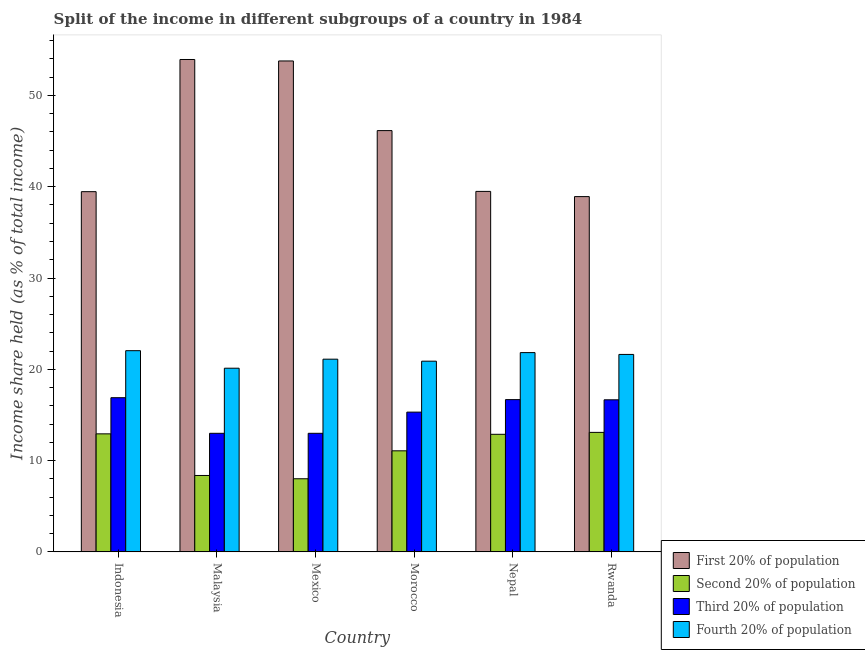How many different coloured bars are there?
Your answer should be very brief. 4. Are the number of bars per tick equal to the number of legend labels?
Make the answer very short. Yes. What is the label of the 4th group of bars from the left?
Offer a very short reply. Morocco. In how many cases, is the number of bars for a given country not equal to the number of legend labels?
Offer a very short reply. 0. What is the share of the income held by first 20% of the population in Malaysia?
Ensure brevity in your answer.  53.94. Across all countries, what is the maximum share of the income held by fourth 20% of the population?
Offer a terse response. 22.04. Across all countries, what is the minimum share of the income held by second 20% of the population?
Make the answer very short. 8.01. In which country was the share of the income held by second 20% of the population maximum?
Offer a terse response. Rwanda. What is the total share of the income held by first 20% of the population in the graph?
Offer a terse response. 271.74. What is the difference between the share of the income held by fourth 20% of the population in Malaysia and that in Morocco?
Offer a terse response. -0.77. What is the difference between the share of the income held by fourth 20% of the population in Mexico and the share of the income held by first 20% of the population in Morocco?
Keep it short and to the point. -25.04. What is the average share of the income held by third 20% of the population per country?
Offer a terse response. 15.25. What is the difference between the share of the income held by fourth 20% of the population and share of the income held by second 20% of the population in Mexico?
Your answer should be very brief. 13.1. In how many countries, is the share of the income held by first 20% of the population greater than 28 %?
Give a very brief answer. 6. What is the ratio of the share of the income held by fourth 20% of the population in Malaysia to that in Morocco?
Keep it short and to the point. 0.96. Is the difference between the share of the income held by third 20% of the population in Malaysia and Nepal greater than the difference between the share of the income held by first 20% of the population in Malaysia and Nepal?
Your answer should be very brief. No. What is the difference between the highest and the second highest share of the income held by second 20% of the population?
Your answer should be compact. 0.16. What is the difference between the highest and the lowest share of the income held by second 20% of the population?
Offer a terse response. 5.08. In how many countries, is the share of the income held by second 20% of the population greater than the average share of the income held by second 20% of the population taken over all countries?
Make the answer very short. 4. Is the sum of the share of the income held by second 20% of the population in Malaysia and Nepal greater than the maximum share of the income held by first 20% of the population across all countries?
Your answer should be compact. No. What does the 4th bar from the left in Nepal represents?
Make the answer very short. Fourth 20% of population. What does the 1st bar from the right in Indonesia represents?
Keep it short and to the point. Fourth 20% of population. How many bars are there?
Make the answer very short. 24. Are all the bars in the graph horizontal?
Offer a very short reply. No. How many countries are there in the graph?
Offer a terse response. 6. What is the difference between two consecutive major ticks on the Y-axis?
Your answer should be very brief. 10. Does the graph contain any zero values?
Your answer should be compact. No. Where does the legend appear in the graph?
Ensure brevity in your answer.  Bottom right. How many legend labels are there?
Make the answer very short. 4. What is the title of the graph?
Your response must be concise. Split of the income in different subgroups of a country in 1984. What is the label or title of the X-axis?
Keep it short and to the point. Country. What is the label or title of the Y-axis?
Your answer should be compact. Income share held (as % of total income). What is the Income share held (as % of total income) in First 20% of population in Indonesia?
Your answer should be very brief. 39.46. What is the Income share held (as % of total income) in Second 20% of population in Indonesia?
Provide a succinct answer. 12.93. What is the Income share held (as % of total income) of Third 20% of population in Indonesia?
Provide a short and direct response. 16.89. What is the Income share held (as % of total income) of Fourth 20% of population in Indonesia?
Provide a succinct answer. 22.04. What is the Income share held (as % of total income) in First 20% of population in Malaysia?
Give a very brief answer. 53.94. What is the Income share held (as % of total income) in Second 20% of population in Malaysia?
Provide a short and direct response. 8.37. What is the Income share held (as % of total income) in Third 20% of population in Malaysia?
Your answer should be very brief. 12.99. What is the Income share held (as % of total income) of Fourth 20% of population in Malaysia?
Provide a succinct answer. 20.12. What is the Income share held (as % of total income) of First 20% of population in Mexico?
Your answer should be very brief. 53.78. What is the Income share held (as % of total income) in Second 20% of population in Mexico?
Offer a very short reply. 8.01. What is the Income share held (as % of total income) in Third 20% of population in Mexico?
Keep it short and to the point. 12.99. What is the Income share held (as % of total income) in Fourth 20% of population in Mexico?
Keep it short and to the point. 21.11. What is the Income share held (as % of total income) in First 20% of population in Morocco?
Keep it short and to the point. 46.15. What is the Income share held (as % of total income) in Second 20% of population in Morocco?
Offer a very short reply. 11.07. What is the Income share held (as % of total income) of Third 20% of population in Morocco?
Offer a very short reply. 15.31. What is the Income share held (as % of total income) in Fourth 20% of population in Morocco?
Give a very brief answer. 20.89. What is the Income share held (as % of total income) of First 20% of population in Nepal?
Give a very brief answer. 39.49. What is the Income share held (as % of total income) of Second 20% of population in Nepal?
Give a very brief answer. 12.88. What is the Income share held (as % of total income) of Third 20% of population in Nepal?
Offer a terse response. 16.68. What is the Income share held (as % of total income) in Fourth 20% of population in Nepal?
Provide a short and direct response. 21.83. What is the Income share held (as % of total income) of First 20% of population in Rwanda?
Provide a succinct answer. 38.92. What is the Income share held (as % of total income) of Second 20% of population in Rwanda?
Offer a very short reply. 13.09. What is the Income share held (as % of total income) in Third 20% of population in Rwanda?
Provide a succinct answer. 16.66. What is the Income share held (as % of total income) of Fourth 20% of population in Rwanda?
Offer a terse response. 21.63. Across all countries, what is the maximum Income share held (as % of total income) in First 20% of population?
Offer a very short reply. 53.94. Across all countries, what is the maximum Income share held (as % of total income) in Second 20% of population?
Keep it short and to the point. 13.09. Across all countries, what is the maximum Income share held (as % of total income) of Third 20% of population?
Offer a terse response. 16.89. Across all countries, what is the maximum Income share held (as % of total income) of Fourth 20% of population?
Keep it short and to the point. 22.04. Across all countries, what is the minimum Income share held (as % of total income) in First 20% of population?
Make the answer very short. 38.92. Across all countries, what is the minimum Income share held (as % of total income) in Second 20% of population?
Offer a very short reply. 8.01. Across all countries, what is the minimum Income share held (as % of total income) in Third 20% of population?
Ensure brevity in your answer.  12.99. Across all countries, what is the minimum Income share held (as % of total income) of Fourth 20% of population?
Provide a short and direct response. 20.12. What is the total Income share held (as % of total income) in First 20% of population in the graph?
Offer a very short reply. 271.74. What is the total Income share held (as % of total income) in Second 20% of population in the graph?
Provide a short and direct response. 66.35. What is the total Income share held (as % of total income) of Third 20% of population in the graph?
Offer a terse response. 91.52. What is the total Income share held (as % of total income) of Fourth 20% of population in the graph?
Provide a succinct answer. 127.62. What is the difference between the Income share held (as % of total income) in First 20% of population in Indonesia and that in Malaysia?
Your answer should be compact. -14.48. What is the difference between the Income share held (as % of total income) of Second 20% of population in Indonesia and that in Malaysia?
Provide a short and direct response. 4.56. What is the difference between the Income share held (as % of total income) in Fourth 20% of population in Indonesia and that in Malaysia?
Provide a short and direct response. 1.92. What is the difference between the Income share held (as % of total income) of First 20% of population in Indonesia and that in Mexico?
Keep it short and to the point. -14.32. What is the difference between the Income share held (as % of total income) in Second 20% of population in Indonesia and that in Mexico?
Ensure brevity in your answer.  4.92. What is the difference between the Income share held (as % of total income) in Fourth 20% of population in Indonesia and that in Mexico?
Make the answer very short. 0.93. What is the difference between the Income share held (as % of total income) of First 20% of population in Indonesia and that in Morocco?
Provide a short and direct response. -6.69. What is the difference between the Income share held (as % of total income) of Second 20% of population in Indonesia and that in Morocco?
Provide a short and direct response. 1.86. What is the difference between the Income share held (as % of total income) in Third 20% of population in Indonesia and that in Morocco?
Keep it short and to the point. 1.58. What is the difference between the Income share held (as % of total income) in Fourth 20% of population in Indonesia and that in Morocco?
Provide a succinct answer. 1.15. What is the difference between the Income share held (as % of total income) in First 20% of population in Indonesia and that in Nepal?
Your response must be concise. -0.03. What is the difference between the Income share held (as % of total income) in Second 20% of population in Indonesia and that in Nepal?
Give a very brief answer. 0.05. What is the difference between the Income share held (as % of total income) in Third 20% of population in Indonesia and that in Nepal?
Ensure brevity in your answer.  0.21. What is the difference between the Income share held (as % of total income) of Fourth 20% of population in Indonesia and that in Nepal?
Your answer should be compact. 0.21. What is the difference between the Income share held (as % of total income) in First 20% of population in Indonesia and that in Rwanda?
Your answer should be compact. 0.54. What is the difference between the Income share held (as % of total income) of Second 20% of population in Indonesia and that in Rwanda?
Offer a very short reply. -0.16. What is the difference between the Income share held (as % of total income) in Third 20% of population in Indonesia and that in Rwanda?
Your response must be concise. 0.23. What is the difference between the Income share held (as % of total income) in Fourth 20% of population in Indonesia and that in Rwanda?
Your answer should be compact. 0.41. What is the difference between the Income share held (as % of total income) in First 20% of population in Malaysia and that in Mexico?
Give a very brief answer. 0.16. What is the difference between the Income share held (as % of total income) in Second 20% of population in Malaysia and that in Mexico?
Provide a short and direct response. 0.36. What is the difference between the Income share held (as % of total income) in Fourth 20% of population in Malaysia and that in Mexico?
Offer a very short reply. -0.99. What is the difference between the Income share held (as % of total income) of First 20% of population in Malaysia and that in Morocco?
Offer a very short reply. 7.79. What is the difference between the Income share held (as % of total income) in Third 20% of population in Malaysia and that in Morocco?
Keep it short and to the point. -2.32. What is the difference between the Income share held (as % of total income) in Fourth 20% of population in Malaysia and that in Morocco?
Provide a succinct answer. -0.77. What is the difference between the Income share held (as % of total income) in First 20% of population in Malaysia and that in Nepal?
Keep it short and to the point. 14.45. What is the difference between the Income share held (as % of total income) in Second 20% of population in Malaysia and that in Nepal?
Offer a terse response. -4.51. What is the difference between the Income share held (as % of total income) of Third 20% of population in Malaysia and that in Nepal?
Give a very brief answer. -3.69. What is the difference between the Income share held (as % of total income) of Fourth 20% of population in Malaysia and that in Nepal?
Your response must be concise. -1.71. What is the difference between the Income share held (as % of total income) in First 20% of population in Malaysia and that in Rwanda?
Your answer should be compact. 15.02. What is the difference between the Income share held (as % of total income) in Second 20% of population in Malaysia and that in Rwanda?
Provide a succinct answer. -4.72. What is the difference between the Income share held (as % of total income) in Third 20% of population in Malaysia and that in Rwanda?
Ensure brevity in your answer.  -3.67. What is the difference between the Income share held (as % of total income) of Fourth 20% of population in Malaysia and that in Rwanda?
Make the answer very short. -1.51. What is the difference between the Income share held (as % of total income) of First 20% of population in Mexico and that in Morocco?
Your answer should be very brief. 7.63. What is the difference between the Income share held (as % of total income) in Second 20% of population in Mexico and that in Morocco?
Offer a very short reply. -3.06. What is the difference between the Income share held (as % of total income) of Third 20% of population in Mexico and that in Morocco?
Ensure brevity in your answer.  -2.32. What is the difference between the Income share held (as % of total income) in Fourth 20% of population in Mexico and that in Morocco?
Give a very brief answer. 0.22. What is the difference between the Income share held (as % of total income) of First 20% of population in Mexico and that in Nepal?
Your answer should be compact. 14.29. What is the difference between the Income share held (as % of total income) in Second 20% of population in Mexico and that in Nepal?
Ensure brevity in your answer.  -4.87. What is the difference between the Income share held (as % of total income) in Third 20% of population in Mexico and that in Nepal?
Your answer should be very brief. -3.69. What is the difference between the Income share held (as % of total income) of Fourth 20% of population in Mexico and that in Nepal?
Make the answer very short. -0.72. What is the difference between the Income share held (as % of total income) in First 20% of population in Mexico and that in Rwanda?
Your answer should be very brief. 14.86. What is the difference between the Income share held (as % of total income) of Second 20% of population in Mexico and that in Rwanda?
Provide a short and direct response. -5.08. What is the difference between the Income share held (as % of total income) in Third 20% of population in Mexico and that in Rwanda?
Provide a short and direct response. -3.67. What is the difference between the Income share held (as % of total income) in Fourth 20% of population in Mexico and that in Rwanda?
Ensure brevity in your answer.  -0.52. What is the difference between the Income share held (as % of total income) of First 20% of population in Morocco and that in Nepal?
Your answer should be compact. 6.66. What is the difference between the Income share held (as % of total income) in Second 20% of population in Morocco and that in Nepal?
Ensure brevity in your answer.  -1.81. What is the difference between the Income share held (as % of total income) in Third 20% of population in Morocco and that in Nepal?
Provide a short and direct response. -1.37. What is the difference between the Income share held (as % of total income) in Fourth 20% of population in Morocco and that in Nepal?
Your answer should be compact. -0.94. What is the difference between the Income share held (as % of total income) of First 20% of population in Morocco and that in Rwanda?
Your answer should be compact. 7.23. What is the difference between the Income share held (as % of total income) of Second 20% of population in Morocco and that in Rwanda?
Offer a terse response. -2.02. What is the difference between the Income share held (as % of total income) in Third 20% of population in Morocco and that in Rwanda?
Provide a succinct answer. -1.35. What is the difference between the Income share held (as % of total income) in Fourth 20% of population in Morocco and that in Rwanda?
Your answer should be very brief. -0.74. What is the difference between the Income share held (as % of total income) of First 20% of population in Nepal and that in Rwanda?
Your answer should be very brief. 0.57. What is the difference between the Income share held (as % of total income) of Second 20% of population in Nepal and that in Rwanda?
Provide a short and direct response. -0.21. What is the difference between the Income share held (as % of total income) in Third 20% of population in Nepal and that in Rwanda?
Ensure brevity in your answer.  0.02. What is the difference between the Income share held (as % of total income) of Fourth 20% of population in Nepal and that in Rwanda?
Provide a short and direct response. 0.2. What is the difference between the Income share held (as % of total income) of First 20% of population in Indonesia and the Income share held (as % of total income) of Second 20% of population in Malaysia?
Provide a succinct answer. 31.09. What is the difference between the Income share held (as % of total income) of First 20% of population in Indonesia and the Income share held (as % of total income) of Third 20% of population in Malaysia?
Make the answer very short. 26.47. What is the difference between the Income share held (as % of total income) of First 20% of population in Indonesia and the Income share held (as % of total income) of Fourth 20% of population in Malaysia?
Provide a succinct answer. 19.34. What is the difference between the Income share held (as % of total income) of Second 20% of population in Indonesia and the Income share held (as % of total income) of Third 20% of population in Malaysia?
Your response must be concise. -0.06. What is the difference between the Income share held (as % of total income) of Second 20% of population in Indonesia and the Income share held (as % of total income) of Fourth 20% of population in Malaysia?
Offer a very short reply. -7.19. What is the difference between the Income share held (as % of total income) in Third 20% of population in Indonesia and the Income share held (as % of total income) in Fourth 20% of population in Malaysia?
Offer a terse response. -3.23. What is the difference between the Income share held (as % of total income) in First 20% of population in Indonesia and the Income share held (as % of total income) in Second 20% of population in Mexico?
Give a very brief answer. 31.45. What is the difference between the Income share held (as % of total income) in First 20% of population in Indonesia and the Income share held (as % of total income) in Third 20% of population in Mexico?
Ensure brevity in your answer.  26.47. What is the difference between the Income share held (as % of total income) in First 20% of population in Indonesia and the Income share held (as % of total income) in Fourth 20% of population in Mexico?
Ensure brevity in your answer.  18.35. What is the difference between the Income share held (as % of total income) of Second 20% of population in Indonesia and the Income share held (as % of total income) of Third 20% of population in Mexico?
Ensure brevity in your answer.  -0.06. What is the difference between the Income share held (as % of total income) in Second 20% of population in Indonesia and the Income share held (as % of total income) in Fourth 20% of population in Mexico?
Provide a succinct answer. -8.18. What is the difference between the Income share held (as % of total income) in Third 20% of population in Indonesia and the Income share held (as % of total income) in Fourth 20% of population in Mexico?
Give a very brief answer. -4.22. What is the difference between the Income share held (as % of total income) of First 20% of population in Indonesia and the Income share held (as % of total income) of Second 20% of population in Morocco?
Give a very brief answer. 28.39. What is the difference between the Income share held (as % of total income) of First 20% of population in Indonesia and the Income share held (as % of total income) of Third 20% of population in Morocco?
Offer a terse response. 24.15. What is the difference between the Income share held (as % of total income) of First 20% of population in Indonesia and the Income share held (as % of total income) of Fourth 20% of population in Morocco?
Offer a terse response. 18.57. What is the difference between the Income share held (as % of total income) in Second 20% of population in Indonesia and the Income share held (as % of total income) in Third 20% of population in Morocco?
Your answer should be compact. -2.38. What is the difference between the Income share held (as % of total income) of Second 20% of population in Indonesia and the Income share held (as % of total income) of Fourth 20% of population in Morocco?
Provide a succinct answer. -7.96. What is the difference between the Income share held (as % of total income) of Third 20% of population in Indonesia and the Income share held (as % of total income) of Fourth 20% of population in Morocco?
Your answer should be compact. -4. What is the difference between the Income share held (as % of total income) of First 20% of population in Indonesia and the Income share held (as % of total income) of Second 20% of population in Nepal?
Make the answer very short. 26.58. What is the difference between the Income share held (as % of total income) in First 20% of population in Indonesia and the Income share held (as % of total income) in Third 20% of population in Nepal?
Keep it short and to the point. 22.78. What is the difference between the Income share held (as % of total income) in First 20% of population in Indonesia and the Income share held (as % of total income) in Fourth 20% of population in Nepal?
Ensure brevity in your answer.  17.63. What is the difference between the Income share held (as % of total income) in Second 20% of population in Indonesia and the Income share held (as % of total income) in Third 20% of population in Nepal?
Keep it short and to the point. -3.75. What is the difference between the Income share held (as % of total income) in Second 20% of population in Indonesia and the Income share held (as % of total income) in Fourth 20% of population in Nepal?
Give a very brief answer. -8.9. What is the difference between the Income share held (as % of total income) in Third 20% of population in Indonesia and the Income share held (as % of total income) in Fourth 20% of population in Nepal?
Make the answer very short. -4.94. What is the difference between the Income share held (as % of total income) of First 20% of population in Indonesia and the Income share held (as % of total income) of Second 20% of population in Rwanda?
Your answer should be very brief. 26.37. What is the difference between the Income share held (as % of total income) in First 20% of population in Indonesia and the Income share held (as % of total income) in Third 20% of population in Rwanda?
Provide a short and direct response. 22.8. What is the difference between the Income share held (as % of total income) of First 20% of population in Indonesia and the Income share held (as % of total income) of Fourth 20% of population in Rwanda?
Ensure brevity in your answer.  17.83. What is the difference between the Income share held (as % of total income) of Second 20% of population in Indonesia and the Income share held (as % of total income) of Third 20% of population in Rwanda?
Offer a terse response. -3.73. What is the difference between the Income share held (as % of total income) in Third 20% of population in Indonesia and the Income share held (as % of total income) in Fourth 20% of population in Rwanda?
Provide a short and direct response. -4.74. What is the difference between the Income share held (as % of total income) of First 20% of population in Malaysia and the Income share held (as % of total income) of Second 20% of population in Mexico?
Offer a very short reply. 45.93. What is the difference between the Income share held (as % of total income) of First 20% of population in Malaysia and the Income share held (as % of total income) of Third 20% of population in Mexico?
Keep it short and to the point. 40.95. What is the difference between the Income share held (as % of total income) of First 20% of population in Malaysia and the Income share held (as % of total income) of Fourth 20% of population in Mexico?
Offer a terse response. 32.83. What is the difference between the Income share held (as % of total income) in Second 20% of population in Malaysia and the Income share held (as % of total income) in Third 20% of population in Mexico?
Ensure brevity in your answer.  -4.62. What is the difference between the Income share held (as % of total income) in Second 20% of population in Malaysia and the Income share held (as % of total income) in Fourth 20% of population in Mexico?
Your answer should be very brief. -12.74. What is the difference between the Income share held (as % of total income) in Third 20% of population in Malaysia and the Income share held (as % of total income) in Fourth 20% of population in Mexico?
Keep it short and to the point. -8.12. What is the difference between the Income share held (as % of total income) of First 20% of population in Malaysia and the Income share held (as % of total income) of Second 20% of population in Morocco?
Provide a short and direct response. 42.87. What is the difference between the Income share held (as % of total income) of First 20% of population in Malaysia and the Income share held (as % of total income) of Third 20% of population in Morocco?
Offer a terse response. 38.63. What is the difference between the Income share held (as % of total income) of First 20% of population in Malaysia and the Income share held (as % of total income) of Fourth 20% of population in Morocco?
Your response must be concise. 33.05. What is the difference between the Income share held (as % of total income) of Second 20% of population in Malaysia and the Income share held (as % of total income) of Third 20% of population in Morocco?
Your answer should be very brief. -6.94. What is the difference between the Income share held (as % of total income) in Second 20% of population in Malaysia and the Income share held (as % of total income) in Fourth 20% of population in Morocco?
Provide a succinct answer. -12.52. What is the difference between the Income share held (as % of total income) in First 20% of population in Malaysia and the Income share held (as % of total income) in Second 20% of population in Nepal?
Make the answer very short. 41.06. What is the difference between the Income share held (as % of total income) of First 20% of population in Malaysia and the Income share held (as % of total income) of Third 20% of population in Nepal?
Give a very brief answer. 37.26. What is the difference between the Income share held (as % of total income) in First 20% of population in Malaysia and the Income share held (as % of total income) in Fourth 20% of population in Nepal?
Provide a short and direct response. 32.11. What is the difference between the Income share held (as % of total income) of Second 20% of population in Malaysia and the Income share held (as % of total income) of Third 20% of population in Nepal?
Provide a succinct answer. -8.31. What is the difference between the Income share held (as % of total income) of Second 20% of population in Malaysia and the Income share held (as % of total income) of Fourth 20% of population in Nepal?
Your answer should be compact. -13.46. What is the difference between the Income share held (as % of total income) in Third 20% of population in Malaysia and the Income share held (as % of total income) in Fourth 20% of population in Nepal?
Your answer should be very brief. -8.84. What is the difference between the Income share held (as % of total income) of First 20% of population in Malaysia and the Income share held (as % of total income) of Second 20% of population in Rwanda?
Your answer should be compact. 40.85. What is the difference between the Income share held (as % of total income) in First 20% of population in Malaysia and the Income share held (as % of total income) in Third 20% of population in Rwanda?
Ensure brevity in your answer.  37.28. What is the difference between the Income share held (as % of total income) of First 20% of population in Malaysia and the Income share held (as % of total income) of Fourth 20% of population in Rwanda?
Offer a very short reply. 32.31. What is the difference between the Income share held (as % of total income) in Second 20% of population in Malaysia and the Income share held (as % of total income) in Third 20% of population in Rwanda?
Your response must be concise. -8.29. What is the difference between the Income share held (as % of total income) in Second 20% of population in Malaysia and the Income share held (as % of total income) in Fourth 20% of population in Rwanda?
Your answer should be very brief. -13.26. What is the difference between the Income share held (as % of total income) of Third 20% of population in Malaysia and the Income share held (as % of total income) of Fourth 20% of population in Rwanda?
Provide a short and direct response. -8.64. What is the difference between the Income share held (as % of total income) in First 20% of population in Mexico and the Income share held (as % of total income) in Second 20% of population in Morocco?
Provide a short and direct response. 42.71. What is the difference between the Income share held (as % of total income) in First 20% of population in Mexico and the Income share held (as % of total income) in Third 20% of population in Morocco?
Provide a short and direct response. 38.47. What is the difference between the Income share held (as % of total income) of First 20% of population in Mexico and the Income share held (as % of total income) of Fourth 20% of population in Morocco?
Your response must be concise. 32.89. What is the difference between the Income share held (as % of total income) in Second 20% of population in Mexico and the Income share held (as % of total income) in Fourth 20% of population in Morocco?
Keep it short and to the point. -12.88. What is the difference between the Income share held (as % of total income) in Third 20% of population in Mexico and the Income share held (as % of total income) in Fourth 20% of population in Morocco?
Ensure brevity in your answer.  -7.9. What is the difference between the Income share held (as % of total income) in First 20% of population in Mexico and the Income share held (as % of total income) in Second 20% of population in Nepal?
Provide a succinct answer. 40.9. What is the difference between the Income share held (as % of total income) of First 20% of population in Mexico and the Income share held (as % of total income) of Third 20% of population in Nepal?
Ensure brevity in your answer.  37.1. What is the difference between the Income share held (as % of total income) in First 20% of population in Mexico and the Income share held (as % of total income) in Fourth 20% of population in Nepal?
Provide a short and direct response. 31.95. What is the difference between the Income share held (as % of total income) of Second 20% of population in Mexico and the Income share held (as % of total income) of Third 20% of population in Nepal?
Keep it short and to the point. -8.67. What is the difference between the Income share held (as % of total income) of Second 20% of population in Mexico and the Income share held (as % of total income) of Fourth 20% of population in Nepal?
Your answer should be very brief. -13.82. What is the difference between the Income share held (as % of total income) in Third 20% of population in Mexico and the Income share held (as % of total income) in Fourth 20% of population in Nepal?
Provide a succinct answer. -8.84. What is the difference between the Income share held (as % of total income) in First 20% of population in Mexico and the Income share held (as % of total income) in Second 20% of population in Rwanda?
Offer a terse response. 40.69. What is the difference between the Income share held (as % of total income) in First 20% of population in Mexico and the Income share held (as % of total income) in Third 20% of population in Rwanda?
Your response must be concise. 37.12. What is the difference between the Income share held (as % of total income) of First 20% of population in Mexico and the Income share held (as % of total income) of Fourth 20% of population in Rwanda?
Offer a very short reply. 32.15. What is the difference between the Income share held (as % of total income) of Second 20% of population in Mexico and the Income share held (as % of total income) of Third 20% of population in Rwanda?
Give a very brief answer. -8.65. What is the difference between the Income share held (as % of total income) in Second 20% of population in Mexico and the Income share held (as % of total income) in Fourth 20% of population in Rwanda?
Ensure brevity in your answer.  -13.62. What is the difference between the Income share held (as % of total income) in Third 20% of population in Mexico and the Income share held (as % of total income) in Fourth 20% of population in Rwanda?
Your answer should be very brief. -8.64. What is the difference between the Income share held (as % of total income) of First 20% of population in Morocco and the Income share held (as % of total income) of Second 20% of population in Nepal?
Provide a short and direct response. 33.27. What is the difference between the Income share held (as % of total income) in First 20% of population in Morocco and the Income share held (as % of total income) in Third 20% of population in Nepal?
Give a very brief answer. 29.47. What is the difference between the Income share held (as % of total income) of First 20% of population in Morocco and the Income share held (as % of total income) of Fourth 20% of population in Nepal?
Your answer should be compact. 24.32. What is the difference between the Income share held (as % of total income) in Second 20% of population in Morocco and the Income share held (as % of total income) in Third 20% of population in Nepal?
Your response must be concise. -5.61. What is the difference between the Income share held (as % of total income) in Second 20% of population in Morocco and the Income share held (as % of total income) in Fourth 20% of population in Nepal?
Keep it short and to the point. -10.76. What is the difference between the Income share held (as % of total income) of Third 20% of population in Morocco and the Income share held (as % of total income) of Fourth 20% of population in Nepal?
Offer a terse response. -6.52. What is the difference between the Income share held (as % of total income) in First 20% of population in Morocco and the Income share held (as % of total income) in Second 20% of population in Rwanda?
Keep it short and to the point. 33.06. What is the difference between the Income share held (as % of total income) of First 20% of population in Morocco and the Income share held (as % of total income) of Third 20% of population in Rwanda?
Your response must be concise. 29.49. What is the difference between the Income share held (as % of total income) in First 20% of population in Morocco and the Income share held (as % of total income) in Fourth 20% of population in Rwanda?
Your answer should be compact. 24.52. What is the difference between the Income share held (as % of total income) in Second 20% of population in Morocco and the Income share held (as % of total income) in Third 20% of population in Rwanda?
Provide a succinct answer. -5.59. What is the difference between the Income share held (as % of total income) in Second 20% of population in Morocco and the Income share held (as % of total income) in Fourth 20% of population in Rwanda?
Keep it short and to the point. -10.56. What is the difference between the Income share held (as % of total income) of Third 20% of population in Morocco and the Income share held (as % of total income) of Fourth 20% of population in Rwanda?
Your answer should be very brief. -6.32. What is the difference between the Income share held (as % of total income) in First 20% of population in Nepal and the Income share held (as % of total income) in Second 20% of population in Rwanda?
Offer a very short reply. 26.4. What is the difference between the Income share held (as % of total income) of First 20% of population in Nepal and the Income share held (as % of total income) of Third 20% of population in Rwanda?
Offer a very short reply. 22.83. What is the difference between the Income share held (as % of total income) of First 20% of population in Nepal and the Income share held (as % of total income) of Fourth 20% of population in Rwanda?
Keep it short and to the point. 17.86. What is the difference between the Income share held (as % of total income) of Second 20% of population in Nepal and the Income share held (as % of total income) of Third 20% of population in Rwanda?
Keep it short and to the point. -3.78. What is the difference between the Income share held (as % of total income) in Second 20% of population in Nepal and the Income share held (as % of total income) in Fourth 20% of population in Rwanda?
Give a very brief answer. -8.75. What is the difference between the Income share held (as % of total income) of Third 20% of population in Nepal and the Income share held (as % of total income) of Fourth 20% of population in Rwanda?
Ensure brevity in your answer.  -4.95. What is the average Income share held (as % of total income) in First 20% of population per country?
Give a very brief answer. 45.29. What is the average Income share held (as % of total income) of Second 20% of population per country?
Offer a terse response. 11.06. What is the average Income share held (as % of total income) of Third 20% of population per country?
Make the answer very short. 15.25. What is the average Income share held (as % of total income) in Fourth 20% of population per country?
Offer a very short reply. 21.27. What is the difference between the Income share held (as % of total income) of First 20% of population and Income share held (as % of total income) of Second 20% of population in Indonesia?
Provide a succinct answer. 26.53. What is the difference between the Income share held (as % of total income) of First 20% of population and Income share held (as % of total income) of Third 20% of population in Indonesia?
Provide a short and direct response. 22.57. What is the difference between the Income share held (as % of total income) in First 20% of population and Income share held (as % of total income) in Fourth 20% of population in Indonesia?
Give a very brief answer. 17.42. What is the difference between the Income share held (as % of total income) in Second 20% of population and Income share held (as % of total income) in Third 20% of population in Indonesia?
Offer a very short reply. -3.96. What is the difference between the Income share held (as % of total income) of Second 20% of population and Income share held (as % of total income) of Fourth 20% of population in Indonesia?
Offer a terse response. -9.11. What is the difference between the Income share held (as % of total income) in Third 20% of population and Income share held (as % of total income) in Fourth 20% of population in Indonesia?
Ensure brevity in your answer.  -5.15. What is the difference between the Income share held (as % of total income) in First 20% of population and Income share held (as % of total income) in Second 20% of population in Malaysia?
Offer a terse response. 45.57. What is the difference between the Income share held (as % of total income) of First 20% of population and Income share held (as % of total income) of Third 20% of population in Malaysia?
Keep it short and to the point. 40.95. What is the difference between the Income share held (as % of total income) in First 20% of population and Income share held (as % of total income) in Fourth 20% of population in Malaysia?
Ensure brevity in your answer.  33.82. What is the difference between the Income share held (as % of total income) of Second 20% of population and Income share held (as % of total income) of Third 20% of population in Malaysia?
Provide a succinct answer. -4.62. What is the difference between the Income share held (as % of total income) of Second 20% of population and Income share held (as % of total income) of Fourth 20% of population in Malaysia?
Offer a terse response. -11.75. What is the difference between the Income share held (as % of total income) of Third 20% of population and Income share held (as % of total income) of Fourth 20% of population in Malaysia?
Offer a very short reply. -7.13. What is the difference between the Income share held (as % of total income) in First 20% of population and Income share held (as % of total income) in Second 20% of population in Mexico?
Keep it short and to the point. 45.77. What is the difference between the Income share held (as % of total income) in First 20% of population and Income share held (as % of total income) in Third 20% of population in Mexico?
Offer a terse response. 40.79. What is the difference between the Income share held (as % of total income) in First 20% of population and Income share held (as % of total income) in Fourth 20% of population in Mexico?
Keep it short and to the point. 32.67. What is the difference between the Income share held (as % of total income) of Second 20% of population and Income share held (as % of total income) of Third 20% of population in Mexico?
Keep it short and to the point. -4.98. What is the difference between the Income share held (as % of total income) of Second 20% of population and Income share held (as % of total income) of Fourth 20% of population in Mexico?
Your answer should be compact. -13.1. What is the difference between the Income share held (as % of total income) of Third 20% of population and Income share held (as % of total income) of Fourth 20% of population in Mexico?
Offer a terse response. -8.12. What is the difference between the Income share held (as % of total income) in First 20% of population and Income share held (as % of total income) in Second 20% of population in Morocco?
Offer a very short reply. 35.08. What is the difference between the Income share held (as % of total income) in First 20% of population and Income share held (as % of total income) in Third 20% of population in Morocco?
Provide a succinct answer. 30.84. What is the difference between the Income share held (as % of total income) in First 20% of population and Income share held (as % of total income) in Fourth 20% of population in Morocco?
Keep it short and to the point. 25.26. What is the difference between the Income share held (as % of total income) of Second 20% of population and Income share held (as % of total income) of Third 20% of population in Morocco?
Offer a terse response. -4.24. What is the difference between the Income share held (as % of total income) of Second 20% of population and Income share held (as % of total income) of Fourth 20% of population in Morocco?
Your answer should be compact. -9.82. What is the difference between the Income share held (as % of total income) of Third 20% of population and Income share held (as % of total income) of Fourth 20% of population in Morocco?
Give a very brief answer. -5.58. What is the difference between the Income share held (as % of total income) in First 20% of population and Income share held (as % of total income) in Second 20% of population in Nepal?
Provide a short and direct response. 26.61. What is the difference between the Income share held (as % of total income) in First 20% of population and Income share held (as % of total income) in Third 20% of population in Nepal?
Keep it short and to the point. 22.81. What is the difference between the Income share held (as % of total income) of First 20% of population and Income share held (as % of total income) of Fourth 20% of population in Nepal?
Ensure brevity in your answer.  17.66. What is the difference between the Income share held (as % of total income) in Second 20% of population and Income share held (as % of total income) in Third 20% of population in Nepal?
Provide a short and direct response. -3.8. What is the difference between the Income share held (as % of total income) in Second 20% of population and Income share held (as % of total income) in Fourth 20% of population in Nepal?
Give a very brief answer. -8.95. What is the difference between the Income share held (as % of total income) in Third 20% of population and Income share held (as % of total income) in Fourth 20% of population in Nepal?
Offer a very short reply. -5.15. What is the difference between the Income share held (as % of total income) of First 20% of population and Income share held (as % of total income) of Second 20% of population in Rwanda?
Your response must be concise. 25.83. What is the difference between the Income share held (as % of total income) of First 20% of population and Income share held (as % of total income) of Third 20% of population in Rwanda?
Keep it short and to the point. 22.26. What is the difference between the Income share held (as % of total income) of First 20% of population and Income share held (as % of total income) of Fourth 20% of population in Rwanda?
Your response must be concise. 17.29. What is the difference between the Income share held (as % of total income) of Second 20% of population and Income share held (as % of total income) of Third 20% of population in Rwanda?
Make the answer very short. -3.57. What is the difference between the Income share held (as % of total income) of Second 20% of population and Income share held (as % of total income) of Fourth 20% of population in Rwanda?
Your answer should be compact. -8.54. What is the difference between the Income share held (as % of total income) in Third 20% of population and Income share held (as % of total income) in Fourth 20% of population in Rwanda?
Your response must be concise. -4.97. What is the ratio of the Income share held (as % of total income) of First 20% of population in Indonesia to that in Malaysia?
Offer a very short reply. 0.73. What is the ratio of the Income share held (as % of total income) in Second 20% of population in Indonesia to that in Malaysia?
Make the answer very short. 1.54. What is the ratio of the Income share held (as % of total income) of Third 20% of population in Indonesia to that in Malaysia?
Make the answer very short. 1.3. What is the ratio of the Income share held (as % of total income) of Fourth 20% of population in Indonesia to that in Malaysia?
Give a very brief answer. 1.1. What is the ratio of the Income share held (as % of total income) of First 20% of population in Indonesia to that in Mexico?
Keep it short and to the point. 0.73. What is the ratio of the Income share held (as % of total income) of Second 20% of population in Indonesia to that in Mexico?
Your answer should be compact. 1.61. What is the ratio of the Income share held (as % of total income) of Third 20% of population in Indonesia to that in Mexico?
Make the answer very short. 1.3. What is the ratio of the Income share held (as % of total income) of Fourth 20% of population in Indonesia to that in Mexico?
Provide a short and direct response. 1.04. What is the ratio of the Income share held (as % of total income) of First 20% of population in Indonesia to that in Morocco?
Offer a very short reply. 0.85. What is the ratio of the Income share held (as % of total income) in Second 20% of population in Indonesia to that in Morocco?
Make the answer very short. 1.17. What is the ratio of the Income share held (as % of total income) in Third 20% of population in Indonesia to that in Morocco?
Ensure brevity in your answer.  1.1. What is the ratio of the Income share held (as % of total income) of Fourth 20% of population in Indonesia to that in Morocco?
Keep it short and to the point. 1.06. What is the ratio of the Income share held (as % of total income) of First 20% of population in Indonesia to that in Nepal?
Offer a very short reply. 1. What is the ratio of the Income share held (as % of total income) of Second 20% of population in Indonesia to that in Nepal?
Your answer should be compact. 1. What is the ratio of the Income share held (as % of total income) of Third 20% of population in Indonesia to that in Nepal?
Provide a succinct answer. 1.01. What is the ratio of the Income share held (as % of total income) in Fourth 20% of population in Indonesia to that in Nepal?
Offer a terse response. 1.01. What is the ratio of the Income share held (as % of total income) of First 20% of population in Indonesia to that in Rwanda?
Offer a very short reply. 1.01. What is the ratio of the Income share held (as % of total income) of Second 20% of population in Indonesia to that in Rwanda?
Keep it short and to the point. 0.99. What is the ratio of the Income share held (as % of total income) in Third 20% of population in Indonesia to that in Rwanda?
Keep it short and to the point. 1.01. What is the ratio of the Income share held (as % of total income) in Fourth 20% of population in Indonesia to that in Rwanda?
Ensure brevity in your answer.  1.02. What is the ratio of the Income share held (as % of total income) of First 20% of population in Malaysia to that in Mexico?
Give a very brief answer. 1. What is the ratio of the Income share held (as % of total income) in Second 20% of population in Malaysia to that in Mexico?
Give a very brief answer. 1.04. What is the ratio of the Income share held (as % of total income) of Fourth 20% of population in Malaysia to that in Mexico?
Give a very brief answer. 0.95. What is the ratio of the Income share held (as % of total income) of First 20% of population in Malaysia to that in Morocco?
Offer a very short reply. 1.17. What is the ratio of the Income share held (as % of total income) of Second 20% of population in Malaysia to that in Morocco?
Your response must be concise. 0.76. What is the ratio of the Income share held (as % of total income) in Third 20% of population in Malaysia to that in Morocco?
Your answer should be very brief. 0.85. What is the ratio of the Income share held (as % of total income) in Fourth 20% of population in Malaysia to that in Morocco?
Keep it short and to the point. 0.96. What is the ratio of the Income share held (as % of total income) in First 20% of population in Malaysia to that in Nepal?
Offer a terse response. 1.37. What is the ratio of the Income share held (as % of total income) in Second 20% of population in Malaysia to that in Nepal?
Make the answer very short. 0.65. What is the ratio of the Income share held (as % of total income) of Third 20% of population in Malaysia to that in Nepal?
Provide a succinct answer. 0.78. What is the ratio of the Income share held (as % of total income) in Fourth 20% of population in Malaysia to that in Nepal?
Make the answer very short. 0.92. What is the ratio of the Income share held (as % of total income) of First 20% of population in Malaysia to that in Rwanda?
Give a very brief answer. 1.39. What is the ratio of the Income share held (as % of total income) of Second 20% of population in Malaysia to that in Rwanda?
Provide a succinct answer. 0.64. What is the ratio of the Income share held (as % of total income) in Third 20% of population in Malaysia to that in Rwanda?
Your response must be concise. 0.78. What is the ratio of the Income share held (as % of total income) of Fourth 20% of population in Malaysia to that in Rwanda?
Your answer should be compact. 0.93. What is the ratio of the Income share held (as % of total income) in First 20% of population in Mexico to that in Morocco?
Provide a short and direct response. 1.17. What is the ratio of the Income share held (as % of total income) of Second 20% of population in Mexico to that in Morocco?
Your answer should be very brief. 0.72. What is the ratio of the Income share held (as % of total income) in Third 20% of population in Mexico to that in Morocco?
Make the answer very short. 0.85. What is the ratio of the Income share held (as % of total income) of Fourth 20% of population in Mexico to that in Morocco?
Ensure brevity in your answer.  1.01. What is the ratio of the Income share held (as % of total income) in First 20% of population in Mexico to that in Nepal?
Provide a short and direct response. 1.36. What is the ratio of the Income share held (as % of total income) of Second 20% of population in Mexico to that in Nepal?
Your response must be concise. 0.62. What is the ratio of the Income share held (as % of total income) in Third 20% of population in Mexico to that in Nepal?
Your response must be concise. 0.78. What is the ratio of the Income share held (as % of total income) in First 20% of population in Mexico to that in Rwanda?
Offer a terse response. 1.38. What is the ratio of the Income share held (as % of total income) in Second 20% of population in Mexico to that in Rwanda?
Your answer should be very brief. 0.61. What is the ratio of the Income share held (as % of total income) in Third 20% of population in Mexico to that in Rwanda?
Offer a terse response. 0.78. What is the ratio of the Income share held (as % of total income) in Fourth 20% of population in Mexico to that in Rwanda?
Your response must be concise. 0.98. What is the ratio of the Income share held (as % of total income) of First 20% of population in Morocco to that in Nepal?
Your answer should be compact. 1.17. What is the ratio of the Income share held (as % of total income) of Second 20% of population in Morocco to that in Nepal?
Your answer should be compact. 0.86. What is the ratio of the Income share held (as % of total income) in Third 20% of population in Morocco to that in Nepal?
Offer a very short reply. 0.92. What is the ratio of the Income share held (as % of total income) of Fourth 20% of population in Morocco to that in Nepal?
Your answer should be very brief. 0.96. What is the ratio of the Income share held (as % of total income) in First 20% of population in Morocco to that in Rwanda?
Keep it short and to the point. 1.19. What is the ratio of the Income share held (as % of total income) in Second 20% of population in Morocco to that in Rwanda?
Provide a short and direct response. 0.85. What is the ratio of the Income share held (as % of total income) of Third 20% of population in Morocco to that in Rwanda?
Your response must be concise. 0.92. What is the ratio of the Income share held (as % of total income) in Fourth 20% of population in Morocco to that in Rwanda?
Offer a very short reply. 0.97. What is the ratio of the Income share held (as % of total income) of First 20% of population in Nepal to that in Rwanda?
Ensure brevity in your answer.  1.01. What is the ratio of the Income share held (as % of total income) in Second 20% of population in Nepal to that in Rwanda?
Offer a very short reply. 0.98. What is the ratio of the Income share held (as % of total income) of Fourth 20% of population in Nepal to that in Rwanda?
Provide a succinct answer. 1.01. What is the difference between the highest and the second highest Income share held (as % of total income) of First 20% of population?
Your response must be concise. 0.16. What is the difference between the highest and the second highest Income share held (as % of total income) of Second 20% of population?
Make the answer very short. 0.16. What is the difference between the highest and the second highest Income share held (as % of total income) of Third 20% of population?
Make the answer very short. 0.21. What is the difference between the highest and the second highest Income share held (as % of total income) of Fourth 20% of population?
Ensure brevity in your answer.  0.21. What is the difference between the highest and the lowest Income share held (as % of total income) in First 20% of population?
Your response must be concise. 15.02. What is the difference between the highest and the lowest Income share held (as % of total income) in Second 20% of population?
Provide a short and direct response. 5.08. What is the difference between the highest and the lowest Income share held (as % of total income) of Third 20% of population?
Keep it short and to the point. 3.9. What is the difference between the highest and the lowest Income share held (as % of total income) in Fourth 20% of population?
Your answer should be very brief. 1.92. 